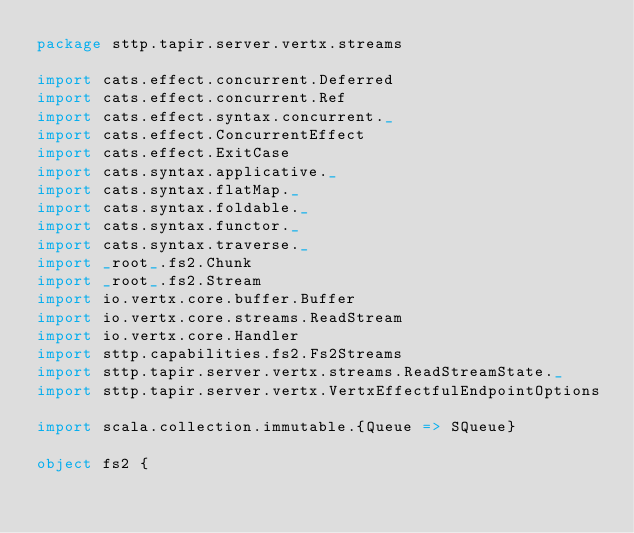<code> <loc_0><loc_0><loc_500><loc_500><_Scala_>package sttp.tapir.server.vertx.streams

import cats.effect.concurrent.Deferred
import cats.effect.concurrent.Ref
import cats.effect.syntax.concurrent._
import cats.effect.ConcurrentEffect
import cats.effect.ExitCase
import cats.syntax.applicative._
import cats.syntax.flatMap._
import cats.syntax.foldable._
import cats.syntax.functor._
import cats.syntax.traverse._
import _root_.fs2.Chunk
import _root_.fs2.Stream
import io.vertx.core.buffer.Buffer
import io.vertx.core.streams.ReadStream
import io.vertx.core.Handler
import sttp.capabilities.fs2.Fs2Streams
import sttp.tapir.server.vertx.streams.ReadStreamState._
import sttp.tapir.server.vertx.VertxEffectfulEndpointOptions

import scala.collection.immutable.{Queue => SQueue}

object fs2 {
</code> 